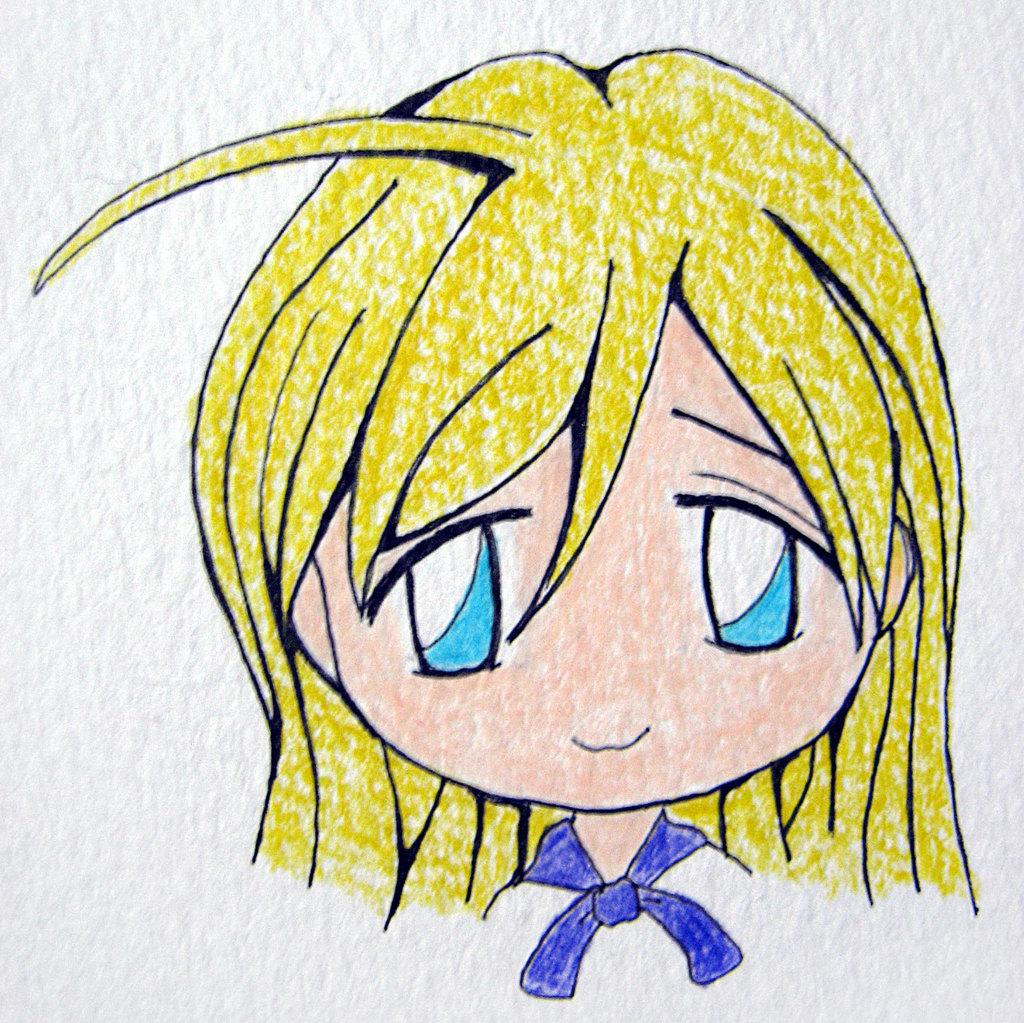What is depicted in the image? There is a painting in the image. What type of subject matter is featured in the painting? The painting is of a cartoon. Where is the painting located? The painting is on a wall. How many teeth can be seen in the painting? There are no teeth visible in the painting, as it is a cartoon and not a representation of a person or animal with teeth. 